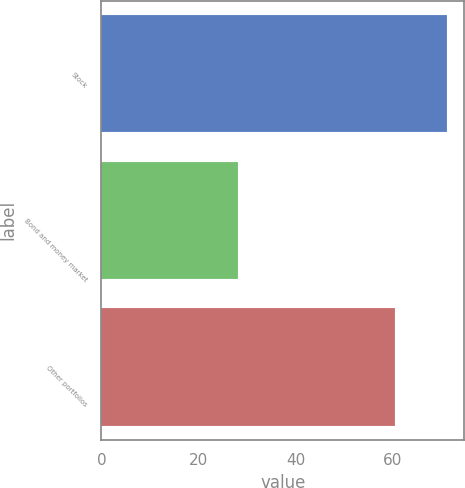Convert chart. <chart><loc_0><loc_0><loc_500><loc_500><bar_chart><fcel>Stock<fcel>Bond and money market<fcel>Other portfolios<nl><fcel>71.2<fcel>28.2<fcel>60.5<nl></chart> 